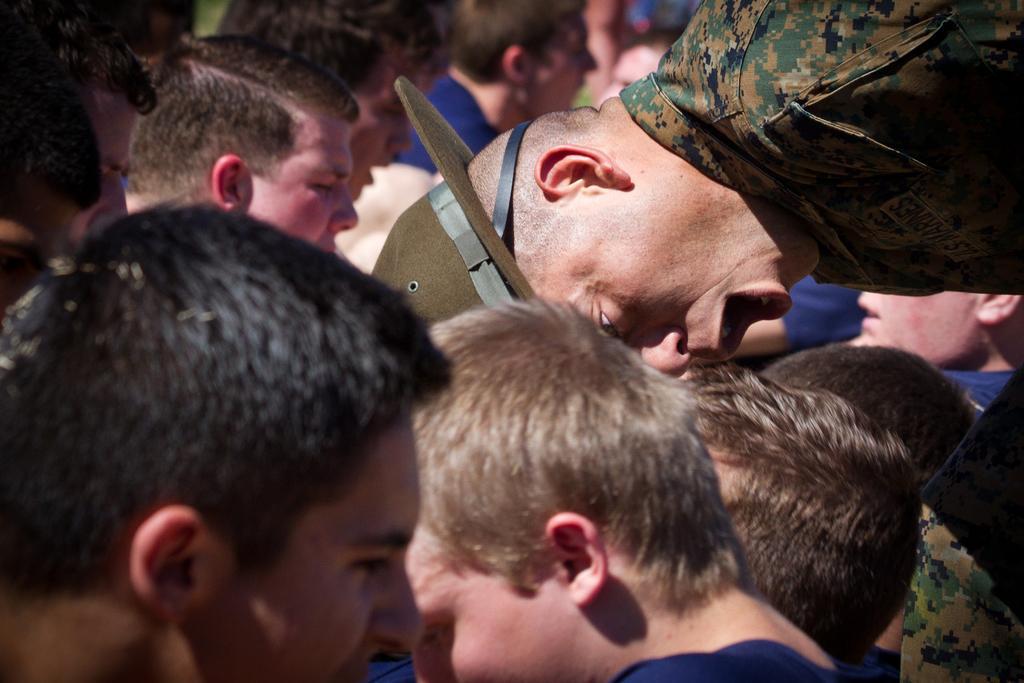Describe this image in one or two sentences. In this picture we can see a group of people, hat and in the background it is blurry. 